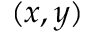Convert formula to latex. <formula><loc_0><loc_0><loc_500><loc_500>( x , y )</formula> 